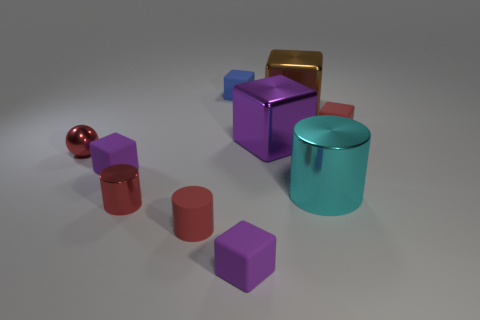Are there more small spheres left of the tiny red cube than yellow rubber cubes?
Give a very brief answer. Yes. There is a red rubber object in front of the red object to the right of the large brown block; what number of big cyan things are left of it?
Your response must be concise. 0. There is a rubber block that is to the right of the brown cube; is its size the same as the purple thing that is left of the blue object?
Give a very brief answer. Yes. What material is the blue thing that is behind the big metallic thing that is in front of the small red shiny sphere?
Your answer should be compact. Rubber. How many things are either large objects that are in front of the big brown metal block or blocks?
Your response must be concise. 7. Are there an equal number of big blocks right of the cyan object and small red things that are on the right side of the blue matte thing?
Keep it short and to the point. No. What is the material of the large block that is in front of the brown thing that is behind the metal block to the left of the brown metal cube?
Provide a short and direct response. Metal. What is the size of the matte cube that is right of the small blue cube and left of the large purple cube?
Offer a very short reply. Small. Is the shape of the small blue rubber object the same as the large brown metal thing?
Offer a very short reply. Yes. There is a large brown object that is the same material as the tiny red ball; what is its shape?
Offer a terse response. Cube. 